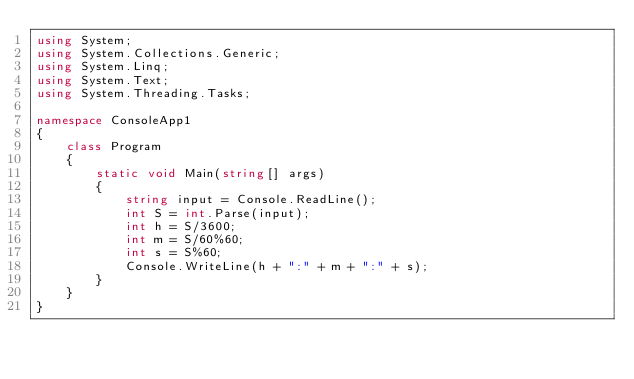<code> <loc_0><loc_0><loc_500><loc_500><_C#_>using System;
using System.Collections.Generic;
using System.Linq;
using System.Text;
using System.Threading.Tasks;

namespace ConsoleApp1
{
    class Program
    {
        static void Main(string[] args)
        {
            string input = Console.ReadLine();
            int S = int.Parse(input);
            int h = S/3600;
            int m = S/60%60;
            int s = S%60;
            Console.WriteLine(h + ":" + m + ":" + s);
        }
    }
}
</code> 